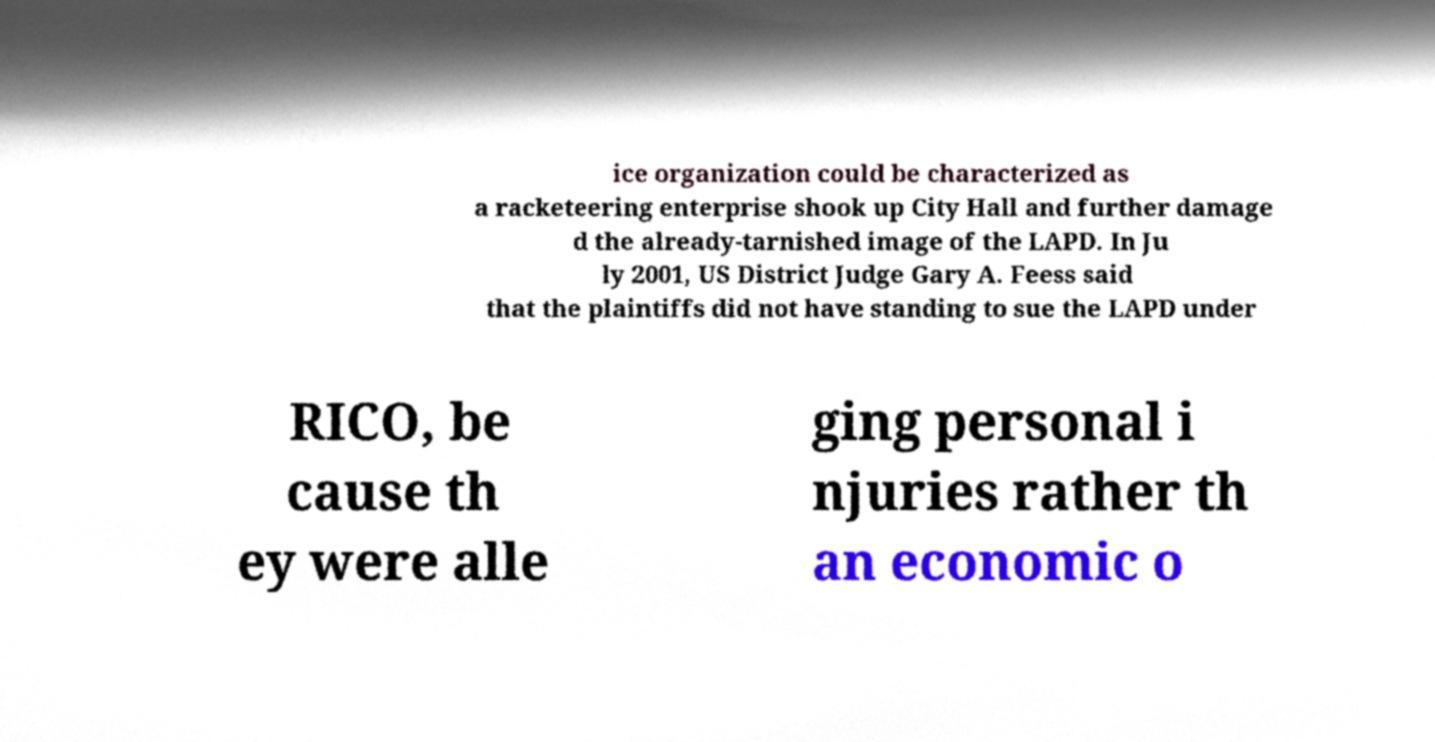I need the written content from this picture converted into text. Can you do that? ice organization could be characterized as a racketeering enterprise shook up City Hall and further damage d the already-tarnished image of the LAPD. In Ju ly 2001, US District Judge Gary A. Feess said that the plaintiffs did not have standing to sue the LAPD under RICO, be cause th ey were alle ging personal i njuries rather th an economic o 